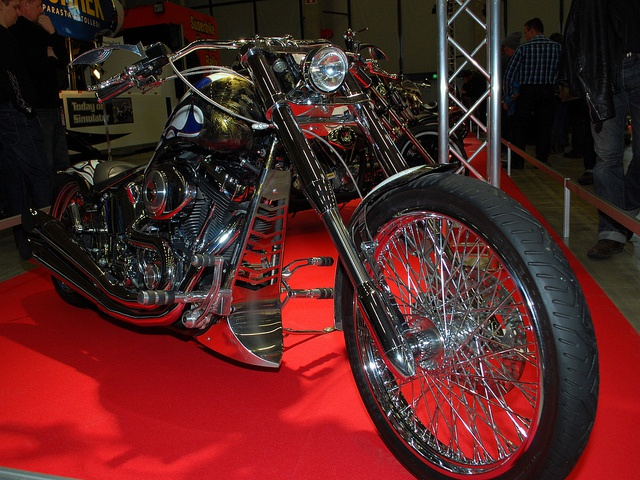Describe the objects in this image and their specific colors. I can see motorcycle in maroon, black, gray, and brown tones, people in maroon, black, and gray tones, people in black, maroon, and gray tones, people in maroon, black, and purple tones, and people in maroon, black, olive, and brown tones in this image. 